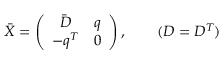Convert formula to latex. <formula><loc_0><loc_0><loc_500><loc_500>\bar { X } = \left ( \begin{array} { c c } { { \bar { D } } } & { q } \\ { { - q ^ { T } } } & { 0 } \end{array} \right ) , ( D = D ^ { T } )</formula> 